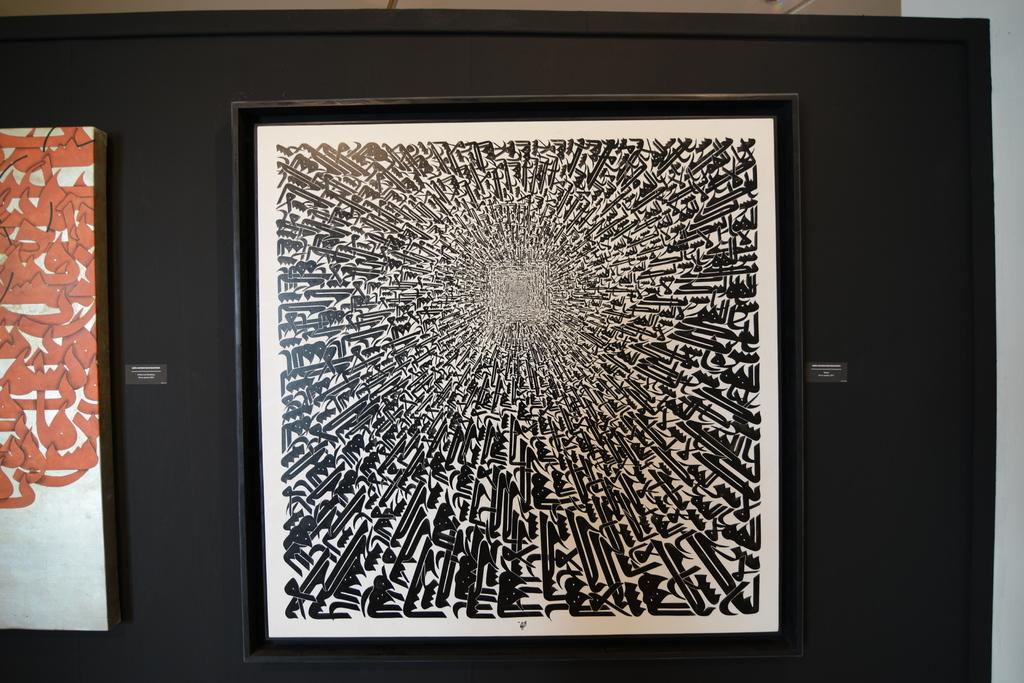How many frames are present in the image? There are two frames in the image. What is the frames attached to in the image? The frames are attached to a blackboard. What type of curtain is hanging in front of the frames in the image? There is no curtain present in the image; it only features two frames attached to a blackboard. Where is the park or party located in the image? There is no park or party present in the image. 